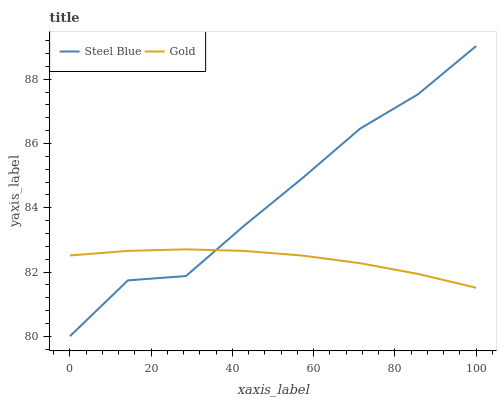Does Gold have the minimum area under the curve?
Answer yes or no. Yes. Does Steel Blue have the maximum area under the curve?
Answer yes or no. Yes. Does Gold have the maximum area under the curve?
Answer yes or no. No. Is Gold the smoothest?
Answer yes or no. Yes. Is Steel Blue the roughest?
Answer yes or no. Yes. Is Gold the roughest?
Answer yes or no. No. Does Gold have the lowest value?
Answer yes or no. No. Does Steel Blue have the highest value?
Answer yes or no. Yes. Does Gold have the highest value?
Answer yes or no. No. Does Steel Blue intersect Gold?
Answer yes or no. Yes. Is Steel Blue less than Gold?
Answer yes or no. No. Is Steel Blue greater than Gold?
Answer yes or no. No. 